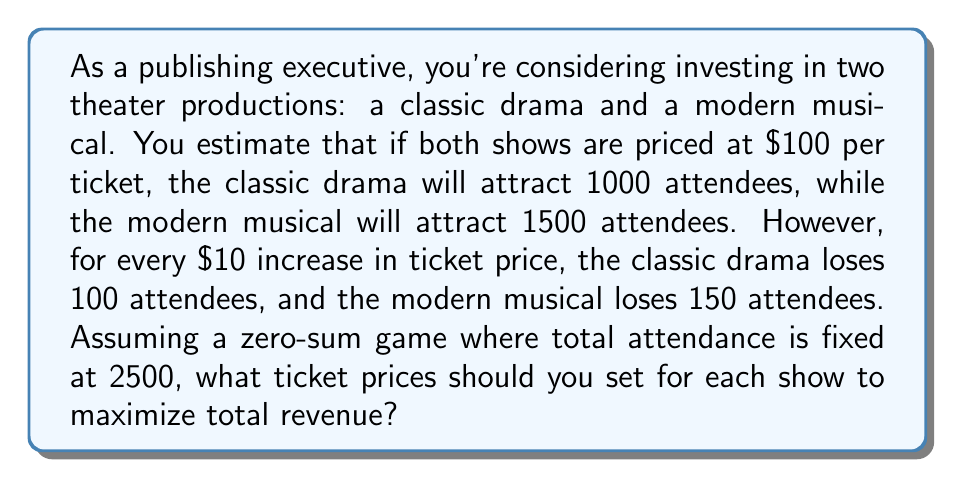Could you help me with this problem? Let's approach this step-by-step using game theory:

1) Let $x$ be the price increase (in $10 increments) for the classic drama, and $y$ be the price increase for the modern musical.

2) The attendance for each show can be modeled as:
   Classic drama: $1000 - 100x$
   Modern musical: $1500 - 150y$

3) Given the zero-sum condition:
   $(1000 - 100x) + (1500 - 150y) = 2500$
   Simplifying: $100x + 150y = 0$
   Or: $2x + 3y = 0$

4) The revenue for each show is price times attendance:
   Classic drama: $(100 + 10x)(1000 - 100x) = 100000 + 10000x - 10000x - 1000x^2 = 100000 - 1000x^2$
   Modern musical: $(100 + 10y)(1500 - 150y) = 150000 + 15000y - 15000y - 1500y^2 = 150000 - 1500y^2$

5) Total revenue: $R = (100000 - 1000x^2) + (150000 - 1500y^2) = 250000 - 1000x^2 - 1500y^2$

6) To maximize R, we need to minimize $1000x^2 + 1500y^2$ subject to the constraint $2x + 3y = 0$

7) Using the method of Lagrange multipliers:
   $L = 1000x^2 + 1500y^2 + \lambda(2x + 3y)$

   $\frac{\partial L}{\partial x} = 2000x + 2\lambda = 0$
   $\frac{\partial L}{\partial y} = 3000y + 3\lambda = 0$
   $\frac{\partial L}{\partial \lambda} = 2x + 3y = 0$

8) From the first two equations:
   $x = -\frac{\lambda}{1000}$ and $y = -\frac{\lambda}{1000}$

9) Substituting into the third equation:
   $2(-\frac{\lambda}{1000}) + 3(-\frac{\lambda}{1000}) = 0$
   $-5\lambda = 0$
   $\lambda = 0$

10) Therefore, $x = y = 0$

This means the optimal strategy is to keep both ticket prices at $100.
Answer: The optimal ticket prices are $100 for both the classic drama and the modern musical. This strategy maximizes total revenue at $250,000. 